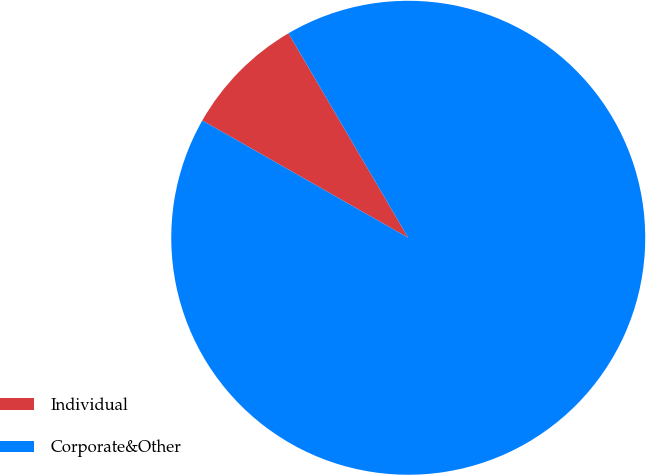<chart> <loc_0><loc_0><loc_500><loc_500><pie_chart><fcel>Individual<fcel>Corporate&Other<nl><fcel>8.33%<fcel>91.67%<nl></chart> 